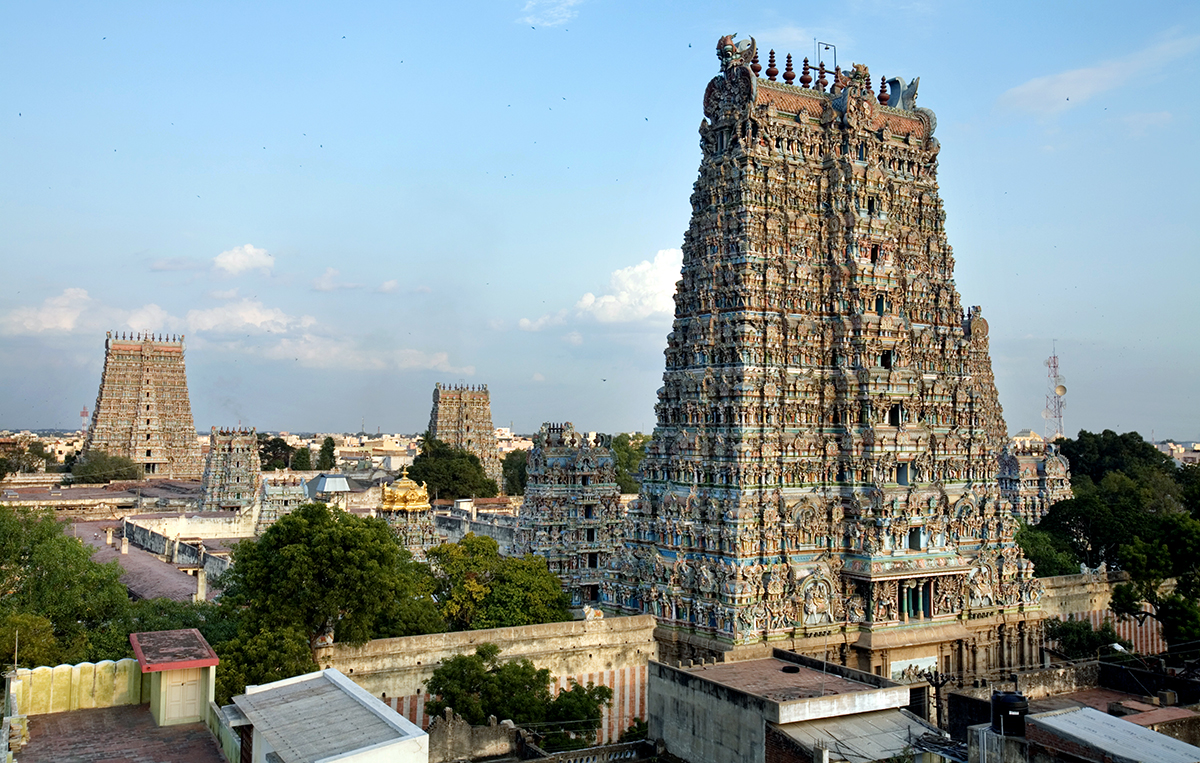What role do the sculptures on the temple play? The sculptures on the Meenakshi Temple serve multiple roles; aesthetically, they are masterpieces of Dravidian art, vividly painted to capture the eye and spirit. They portray an array of divine figures and mythical themes, educating devotees and visitors about Hindu mythology and spiritual beliefs. Functionally, these statues are integral to the temple’s architecture, enhancing its sacred ambiance and supporting spiritual contemplation among worshippers. 